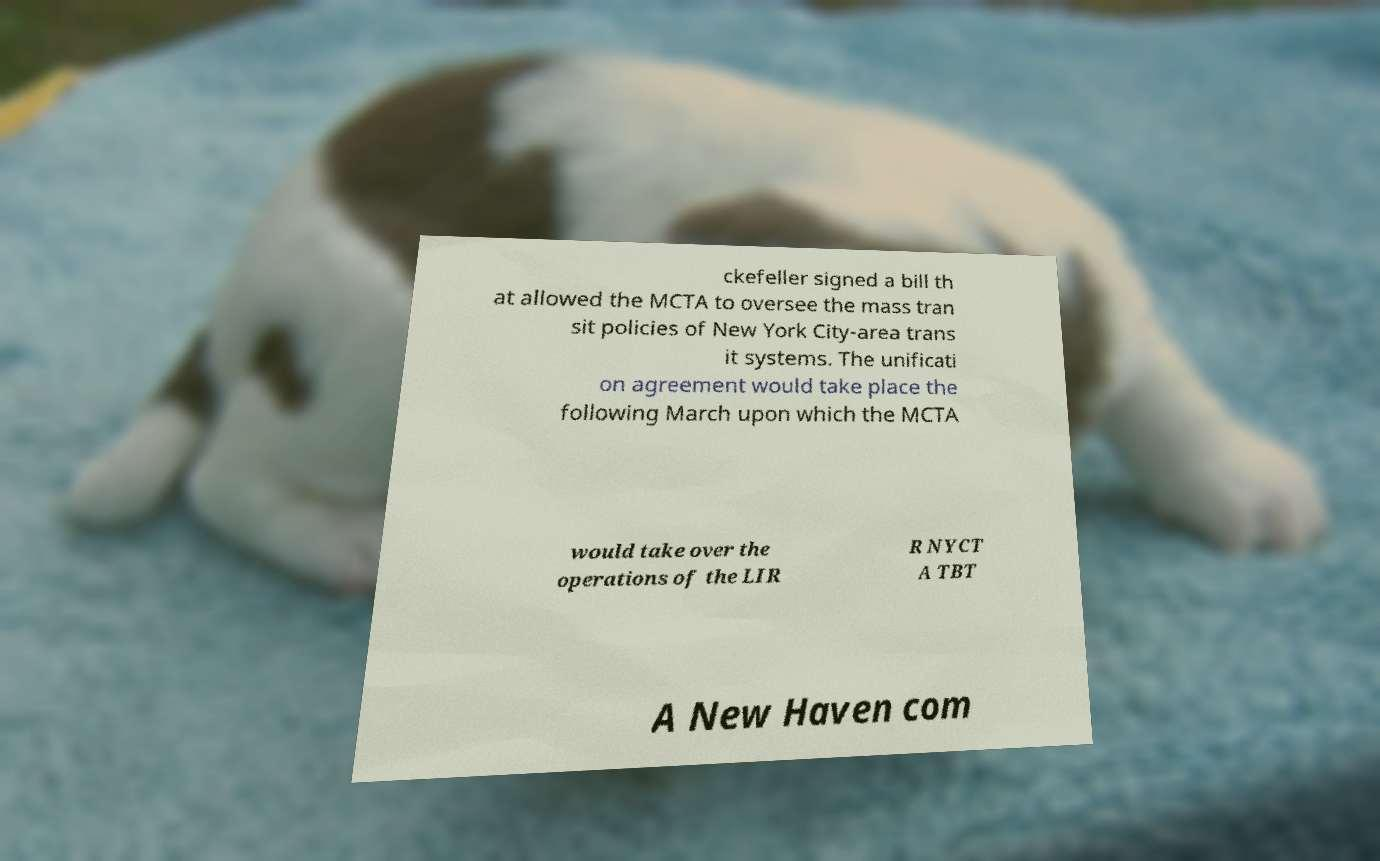Can you accurately transcribe the text from the provided image for me? ckefeller signed a bill th at allowed the MCTA to oversee the mass tran sit policies of New York City-area trans it systems. The unificati on agreement would take place the following March upon which the MCTA would take over the operations of the LIR R NYCT A TBT A New Haven com 